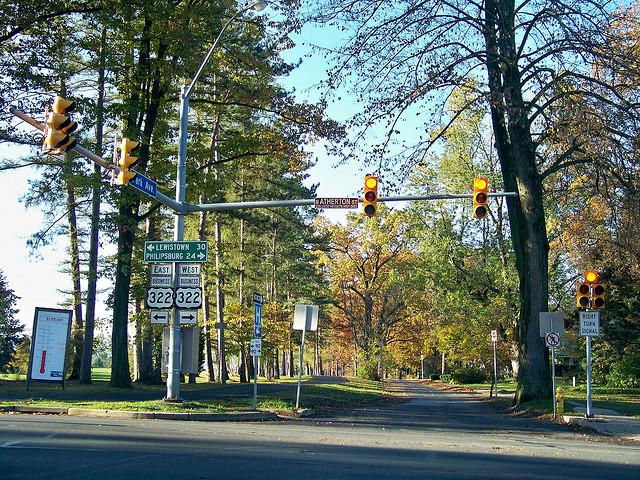How many signal lights are in the picture?
Answer briefly. 5. What color is the light?
Concise answer only. Yellow. What does the thermometer on the sign to the left indicate?
Answer briefly. Temperature. What color is the signal light?
Be succinct. Yellow. 